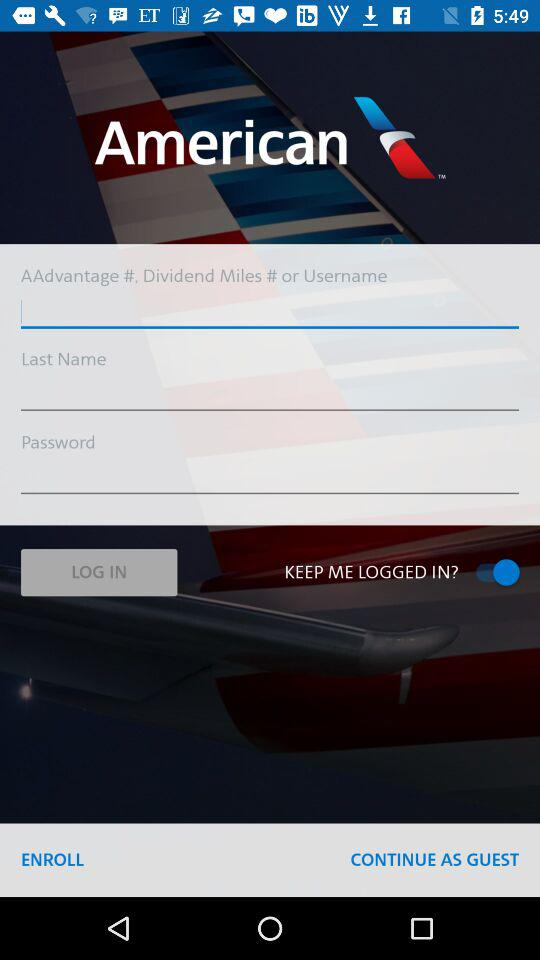What is the name of the application?
When the provided information is insufficient, respond with <no answer>. <no answer> 